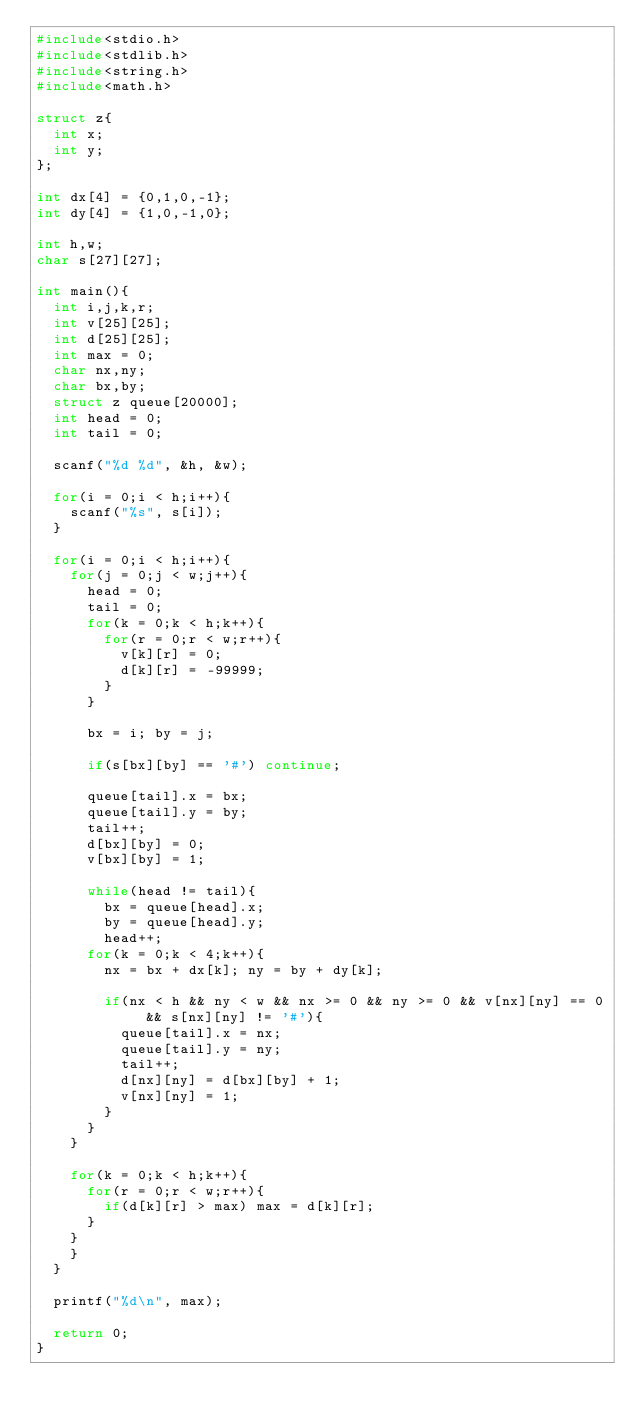<code> <loc_0><loc_0><loc_500><loc_500><_C_>#include<stdio.h>
#include<stdlib.h>
#include<string.h>
#include<math.h>

struct z{
  int x;
  int y;
};

int dx[4] = {0,1,0,-1};
int dy[4] = {1,0,-1,0};

int h,w;
char s[27][27];

int main(){
  int i,j,k,r;
  int v[25][25];
  int d[25][25];
  int max = 0;
  char nx,ny;
  char bx,by;
  struct z queue[20000];
  int head = 0;
  int tail = 0;

  scanf("%d %d", &h, &w);

  for(i = 0;i < h;i++){
    scanf("%s", s[i]);
  }

  for(i = 0;i < h;i++){
    for(j = 0;j < w;j++){
      head = 0;
      tail = 0;
      for(k = 0;k < h;k++){
        for(r = 0;r < w;r++){
          v[k][r] = 0;
          d[k][r] = -99999;
        }
      }

      bx = i; by = j;

      if(s[bx][by] == '#') continue;

      queue[tail].x = bx;
      queue[tail].y = by;
      tail++;
      d[bx][by] = 0;
      v[bx][by] = 1;

      while(head != tail){
        bx = queue[head].x;
        by = queue[head].y;
        head++;
      for(k = 0;k < 4;k++){
        nx = bx + dx[k]; ny = by + dy[k];

        if(nx < h && ny < w && nx >= 0 && ny >= 0 && v[nx][ny] == 0 && s[nx][ny] != '#'){
          queue[tail].x = nx;
          queue[tail].y = ny;
          tail++;
          d[nx][ny] = d[bx][by] + 1;
          v[nx][ny] = 1;
        }
      }
    }

    for(k = 0;k < h;k++){
      for(r = 0;r < w;r++){
        if(d[k][r] > max) max = d[k][r];
      }
    }
    }
  }

  printf("%d\n", max);

  return 0;
}
</code> 